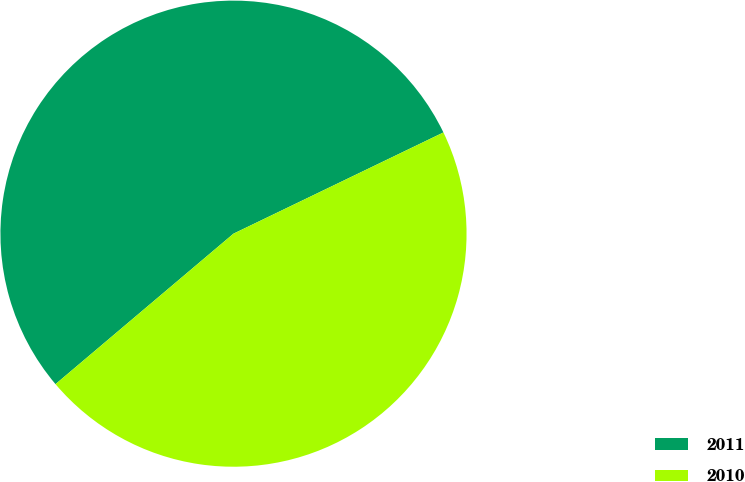Convert chart to OTSL. <chart><loc_0><loc_0><loc_500><loc_500><pie_chart><fcel>2011<fcel>2010<nl><fcel>54.02%<fcel>45.98%<nl></chart> 